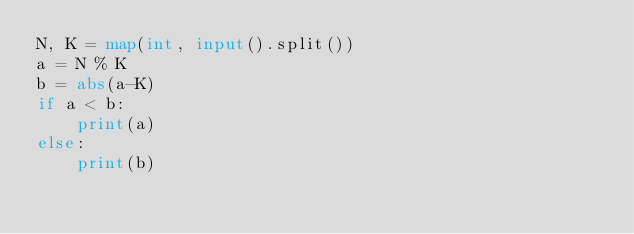<code> <loc_0><loc_0><loc_500><loc_500><_Python_>N, K = map(int, input().split())
a = N % K
b = abs(a-K)
if a < b:
    print(a)
else:
    print(b)</code> 